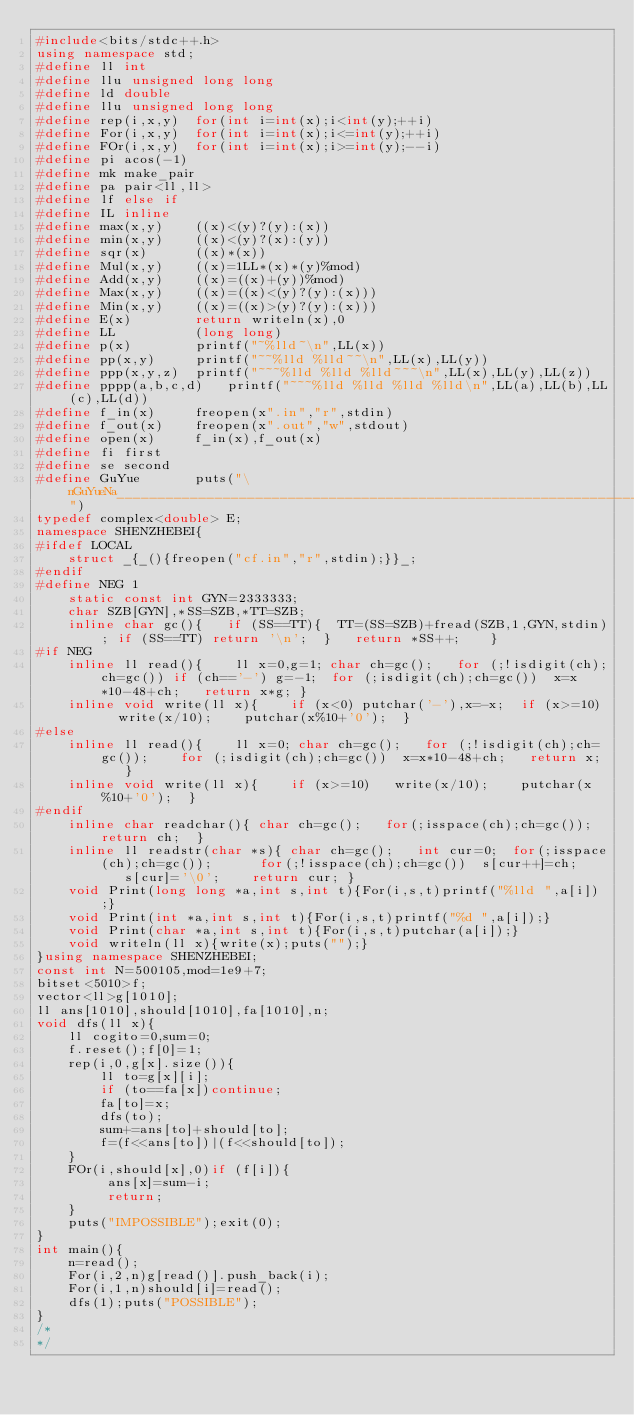<code> <loc_0><loc_0><loc_500><loc_500><_C++_>#include<bits/stdc++.h>
using namespace std;
#define ll int
#define llu unsigned long long
#define ld double
#define llu unsigned long long
#define rep(i,x,y)  for(int i=int(x);i<int(y);++i)
#define For(i,x,y)  for(int i=int(x);i<=int(y);++i)
#define FOr(i,x,y)  for(int i=int(x);i>=int(y);--i)
#define pi acos(-1) 
#define mk make_pair
#define pa pair<ll,ll>
#define lf else if
#define IL inline
#define max(x,y)    ((x)<(y)?(y):(x))
#define min(x,y)    ((x)<(y)?(x):(y))
#define sqr(x)      ((x)*(x))
#define Mul(x,y)    ((x)=1LL*(x)*(y)%mod)
#define Add(x,y)    ((x)=((x)+(y))%mod)
#define Max(x,y)    ((x)=((x)<(y)?(y):(x)))
#define Min(x,y)    ((x)=((x)>(y)?(y):(x)))
#define E(x)        return writeln(x),0
#define LL			(long long)
#define p(x)        printf("~%lld~\n",LL(x))
#define pp(x,y)     printf("~~%lld %lld~~\n",LL(x),LL(y))
#define ppp(x,y,z)  printf("~~~%lld %lld %lld~~~\n",LL(x),LL(y),LL(z))
#define pppp(a,b,c,d)	printf("~~~%lld %lld %lld %lld\n",LL(a),LL(b),LL(c),LL(d))
#define f_in(x)     freopen(x".in","r",stdin)
#define f_out(x)    freopen(x".out","w",stdout)
#define open(x)     f_in(x),f_out(x)
#define fi first
#define se second
#define GuYue		puts("\nGuYueNa________________________________________________________________________________")
typedef complex<double> E;
namespace SHENZHEBEI{
#ifdef LOCAL
    struct _{_(){freopen("cf.in","r",stdin);}}_; 
#endif 
#define NEG 1
    static const int GYN=2333333;
    char SZB[GYN],*SS=SZB,*TT=SZB;
    inline char gc(){   if (SS==TT){  TT=(SS=SZB)+fread(SZB,1,GYN,stdin); if (SS==TT) return '\n';  }   return *SS++;    }
#if NEG
    inline ll read(){    ll x=0,g=1; char ch=gc();   for (;!isdigit(ch);ch=gc()) if (ch=='-') g=-1;  for (;isdigit(ch);ch=gc())  x=x*10-48+ch;   return x*g; }
    inline void write(ll x){    if (x<0) putchar('-'),x=-x;  if (x>=10)   write(x/10);    putchar(x%10+'0');  }
#else
    inline ll read(){    ll x=0; char ch=gc();   for (;!isdigit(ch);ch=gc());    for (;isdigit(ch);ch=gc())  x=x*10-48+ch;   return x;   }
    inline void write(ll x){    if (x>=10)   write(x/10);    putchar(x%10+'0');  }
#endif
    inline char readchar(){ char ch=gc();   for(;isspace(ch);ch=gc());  return ch;  }
    inline ll readstr(char *s){ char ch=gc();   int cur=0;  for(;isspace(ch);ch=gc());      for(;!isspace(ch);ch=gc())  s[cur++]=ch;    s[cur]='\0';    return cur; }
	void Print(long long *a,int s,int t){For(i,s,t)printf("%lld ",a[i]);}
	void Print(int *a,int s,int t){For(i,s,t)printf("%d ",a[i]);}
	void Print(char *a,int s,int t){For(i,s,t)putchar(a[i]);}
	void writeln(ll x){write(x);puts("");}
}using namespace SHENZHEBEI;
const int N=500105,mod=1e9+7;
bitset<5010>f;
vector<ll>g[1010];
ll ans[1010],should[1010],fa[1010],n;
void dfs(ll x){
	ll cogito=0,sum=0;
	f.reset();f[0]=1;
	rep(i,0,g[x].size()){
		ll to=g[x][i];
		if (to==fa[x])continue;
		fa[to]=x;
		dfs(to);
		sum+=ans[to]+should[to];
		f=(f<<ans[to])|(f<<should[to]);
	}
	FOr(i,should[x],0)if (f[i]){
		 ans[x]=sum-i;
		 return;
	}
	puts("IMPOSSIBLE");exit(0);
}
int main(){
	n=read();
	For(i,2,n)g[read()].push_back(i);
	For(i,1,n)should[i]=read();
	dfs(1);puts("POSSIBLE");
}
/*
*/</code> 